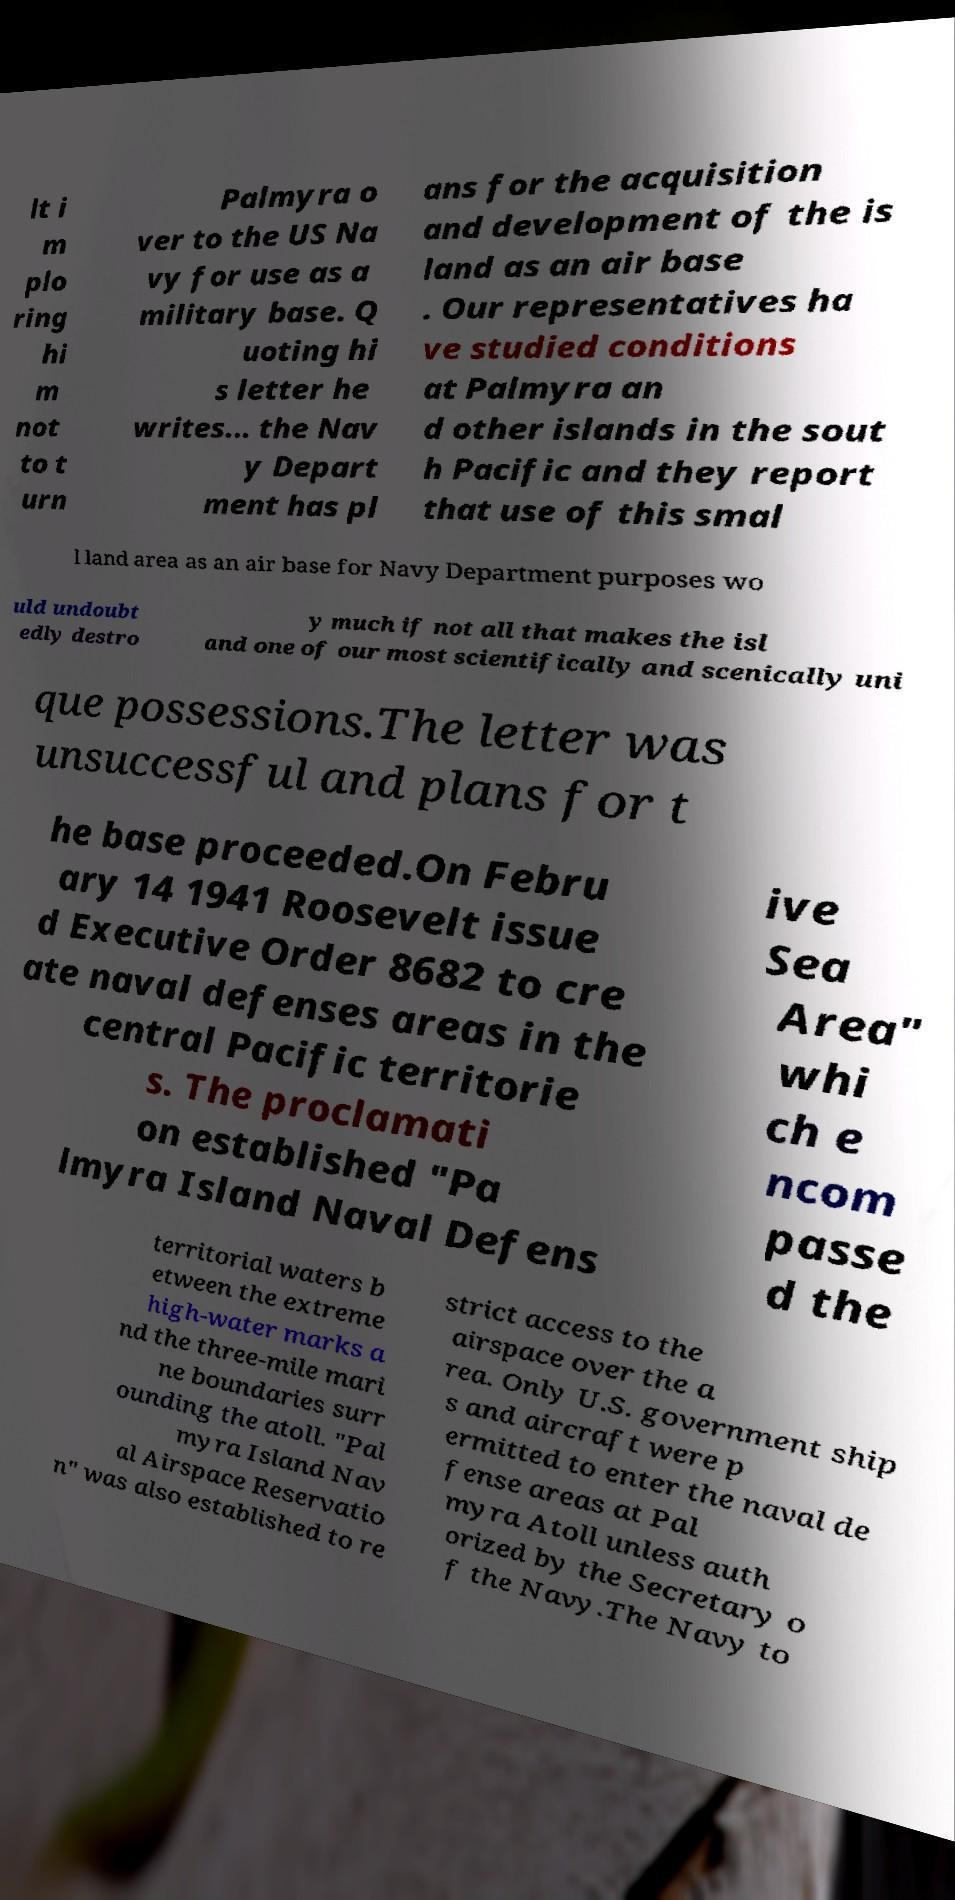There's text embedded in this image that I need extracted. Can you transcribe it verbatim? lt i m plo ring hi m not to t urn Palmyra o ver to the US Na vy for use as a military base. Q uoting hi s letter he writes... the Nav y Depart ment has pl ans for the acquisition and development of the is land as an air base . Our representatives ha ve studied conditions at Palmyra an d other islands in the sout h Pacific and they report that use of this smal l land area as an air base for Navy Department purposes wo uld undoubt edly destro y much if not all that makes the isl and one of our most scientifically and scenically uni que possessions.The letter was unsuccessful and plans for t he base proceeded.On Febru ary 14 1941 Roosevelt issue d Executive Order 8682 to cre ate naval defenses areas in the central Pacific territorie s. The proclamati on established "Pa lmyra Island Naval Defens ive Sea Area" whi ch e ncom passe d the territorial waters b etween the extreme high-water marks a nd the three-mile mari ne boundaries surr ounding the atoll. "Pal myra Island Nav al Airspace Reservatio n" was also established to re strict access to the airspace over the a rea. Only U.S. government ship s and aircraft were p ermitted to enter the naval de fense areas at Pal myra Atoll unless auth orized by the Secretary o f the Navy.The Navy to 